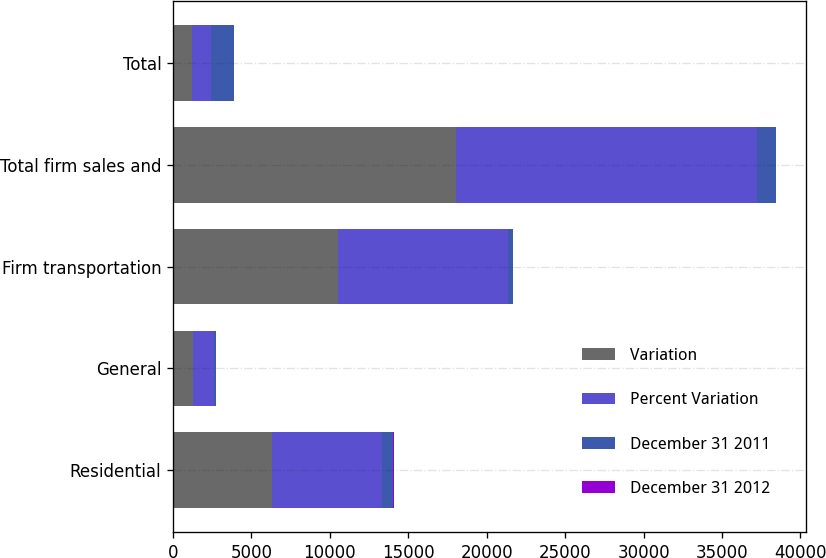Convert chart to OTSL. <chart><loc_0><loc_0><loc_500><loc_500><stacked_bar_chart><ecel><fcel>Residential<fcel>General<fcel>Firm transportation<fcel>Total firm sales and<fcel>Total<nl><fcel>Variation<fcel>6291<fcel>1248<fcel>10505<fcel>18044<fcel>1205.5<nl><fcel>Percent Variation<fcel>7024<fcel>1360<fcel>10823<fcel>19207<fcel>1205.5<nl><fcel>December 31 2011<fcel>733<fcel>112<fcel>318<fcel>1163<fcel>1463<nl><fcel>December 31 2012<fcel>10.4<fcel>8.2<fcel>2.9<fcel>6.1<fcel>5.8<nl></chart> 